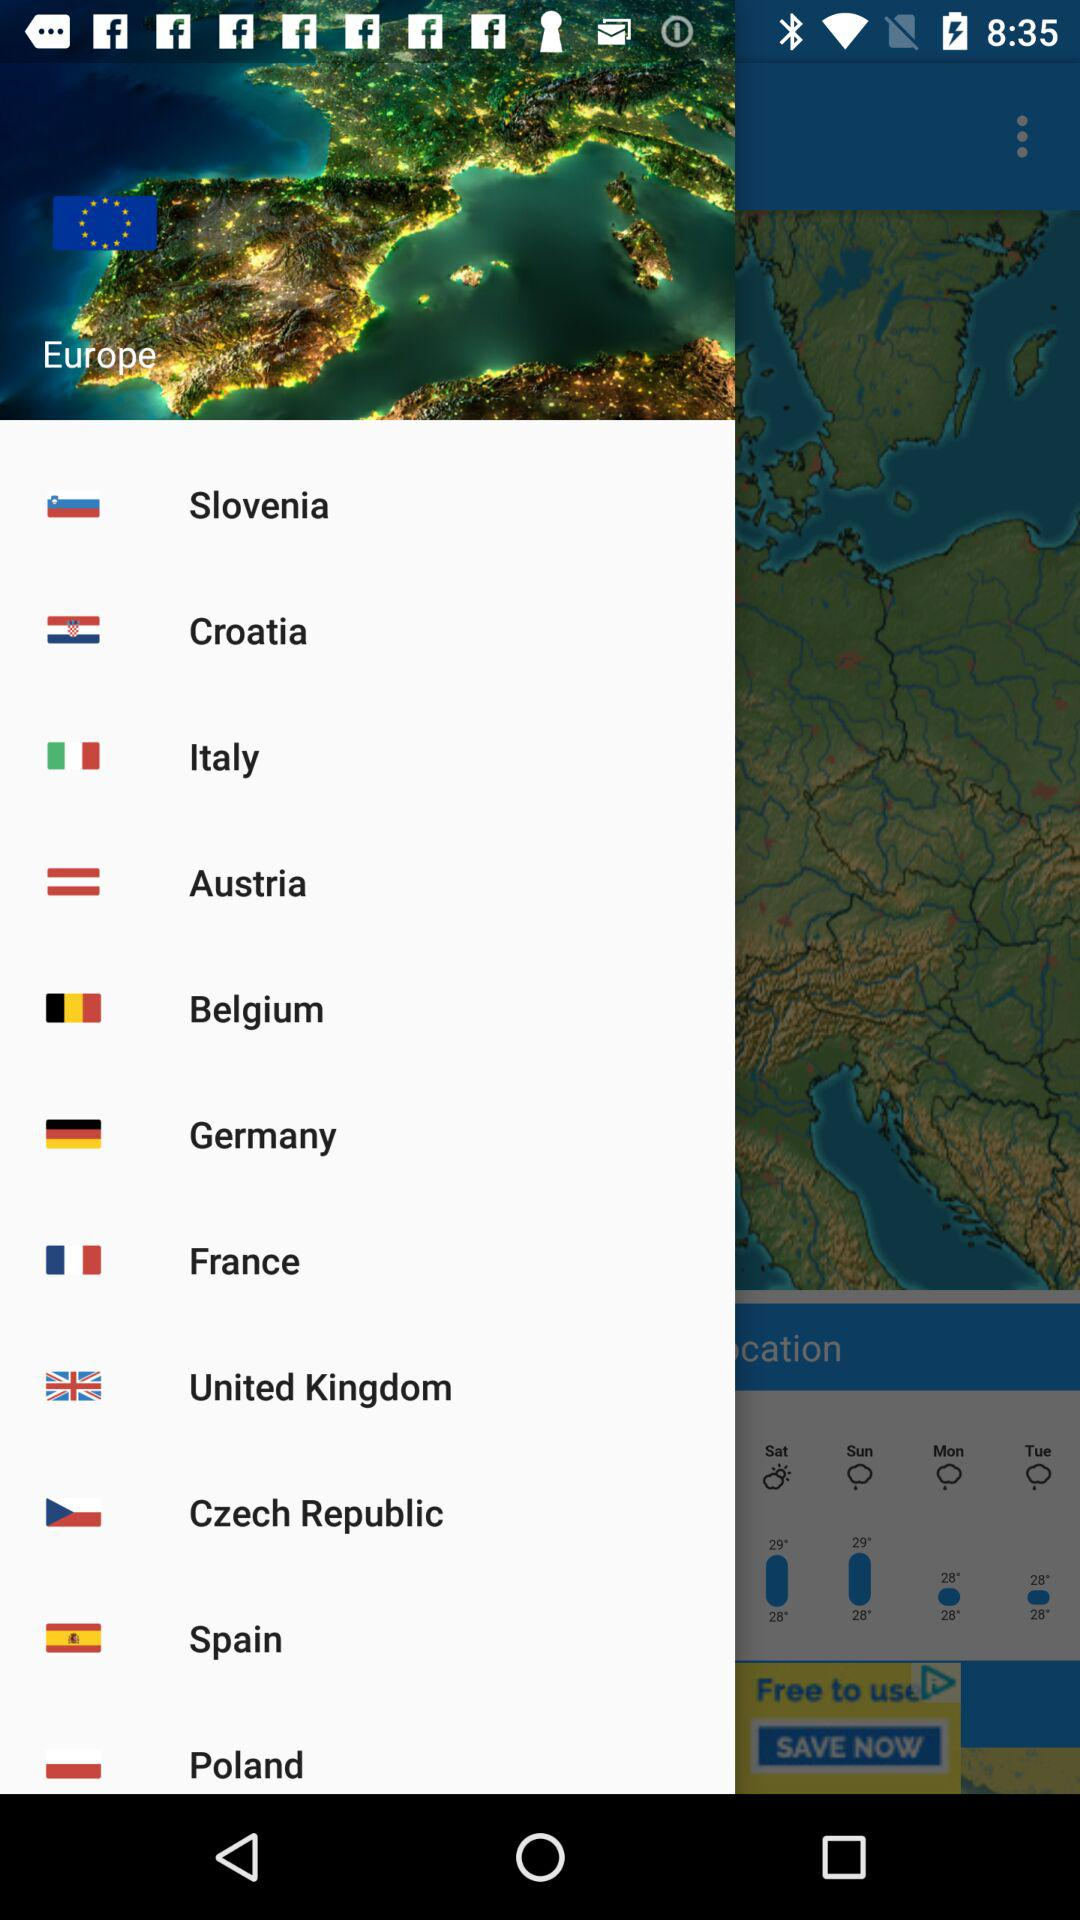What is the continent? The continent is Europe. 